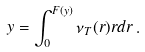<formula> <loc_0><loc_0><loc_500><loc_500>y = \int _ { 0 } ^ { F ( y ) } \nu _ { T } ( r ) r d r \, .</formula> 